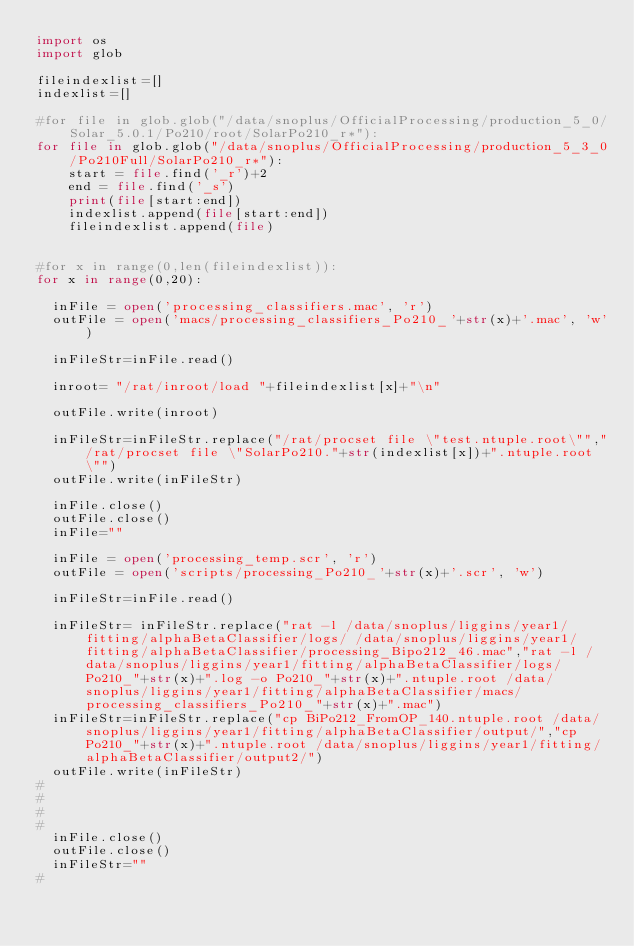<code> <loc_0><loc_0><loc_500><loc_500><_Python_>import os 
import glob

fileindexlist=[]
indexlist=[]

#for file in glob.glob("/data/snoplus/OfficialProcessing/production_5_0/Solar_5.0.1/Po210/root/SolarPo210_r*"):
for file in glob.glob("/data/snoplus/OfficialProcessing/production_5_3_0/Po210Full/SolarPo210_r*"):
    start = file.find('_r')+2
    end = file.find('_s')
    print(file[start:end])
    indexlist.append(file[start:end])
    fileindexlist.append(file)


#for x in range(0,len(fileindexlist)):
for x in range(0,20):

	inFile = open('processing_classifiers.mac', 'r')
	outFile = open('macs/processing_classifiers_Po210_'+str(x)+'.mac', 'w')
	
	inFileStr=inFile.read()

	inroot= "/rat/inroot/load "+fileindexlist[x]+"\n"

	outFile.write(inroot)

	inFileStr=inFileStr.replace("/rat/procset file \"test.ntuple.root\"","/rat/procset file \"SolarPo210."+str(indexlist[x])+".ntuple.root\"")
	outFile.write(inFileStr)

	inFile.close()
	outFile.close()
	inFile=""

	inFile = open('processing_temp.scr', 'r')
	outFile = open('scripts/processing_Po210_'+str(x)+'.scr', 'w')

	inFileStr=inFile.read()

	inFileStr= inFileStr.replace("rat -l /data/snoplus/liggins/year1/fitting/alphaBetaClassifier/logs/ /data/snoplus/liggins/year1/fitting/alphaBetaClassifier/processing_Bipo212_46.mac","rat -l /data/snoplus/liggins/year1/fitting/alphaBetaClassifier/logs/Po210_"+str(x)+".log -o Po210_"+str(x)+".ntuple.root /data/snoplus/liggins/year1/fitting/alphaBetaClassifier/macs/processing_classifiers_Po210_"+str(x)+".mac") 
	inFileStr=inFileStr.replace("cp BiPo212_FromOP_140.ntuple.root /data/snoplus/liggins/year1/fitting/alphaBetaClassifier/output/","cp Po210_"+str(x)+".ntuple.root /data/snoplus/liggins/year1/fitting/alphaBetaClassifier/output2/")
	outFile.write(inFileStr)
#
#	
#
#
	inFile.close()
	outFile.close()
	inFileStr=""
#</code> 